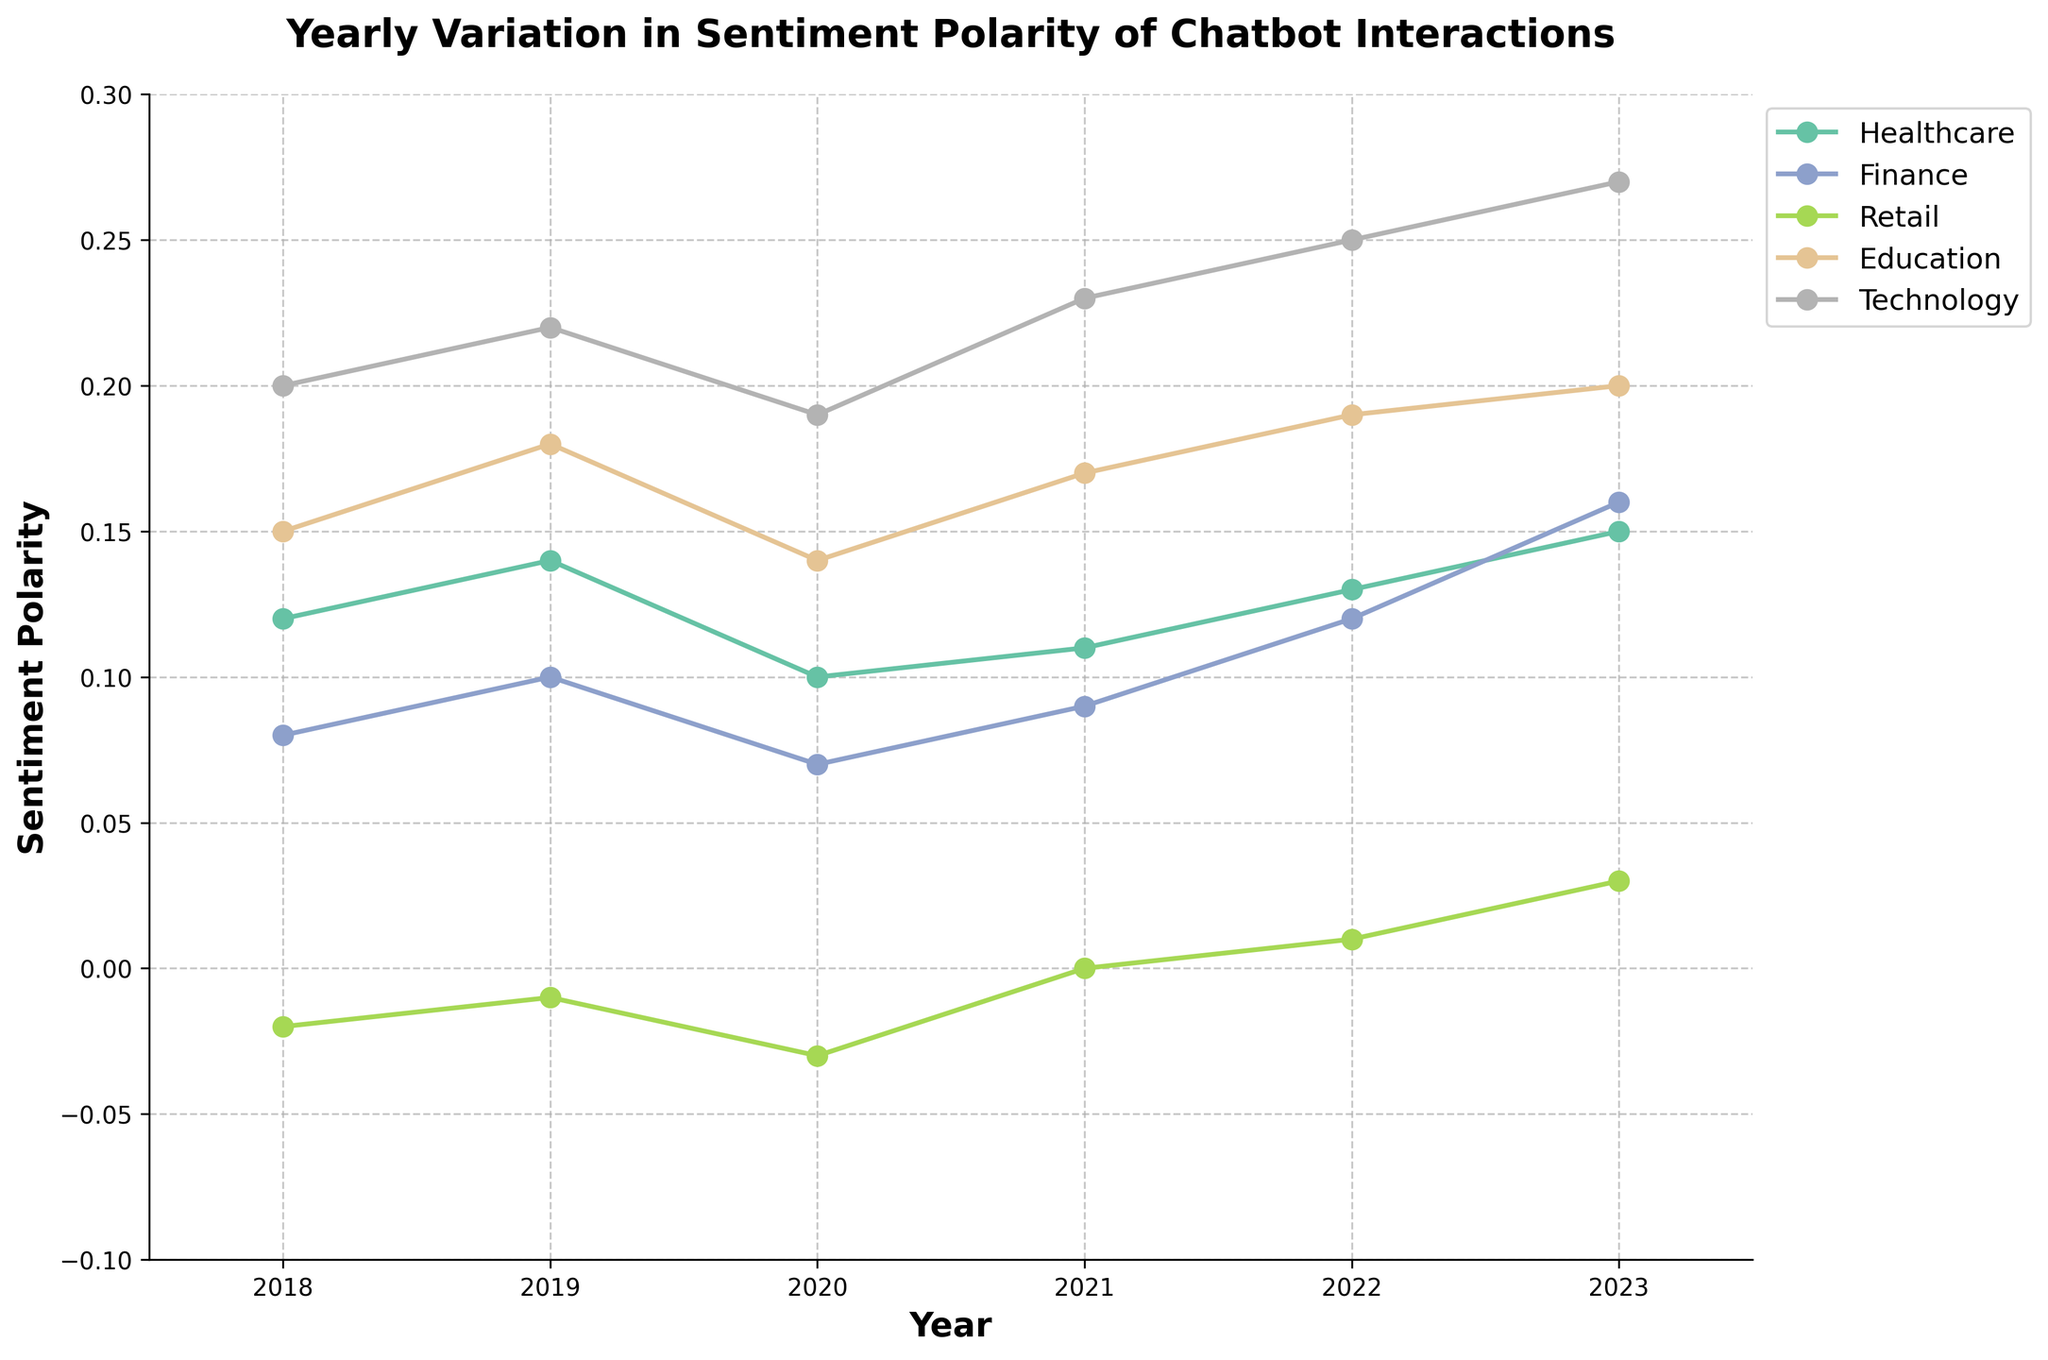What is the title of the plot? The title is positioned above the plot; it gives a summary of what the plot is displaying.
Answer: Yearly Variation in Sentiment Polarity of Chatbot Interactions What year had the lowest sentiment polarity for the Retail industry? The Retail industry line graph shows a dip around 2020 at the bottom of the plot.
Answer: 2020 Which industry had the highest sentiment polarity in 2023? By looking at the endpoint of 2023 for each industry, the Technology industry reaches the highest point.
Answer: Technology How did the sentiment polarity of the Healthcare industry change from 2018 to 2023? Trace the Healthcare line from 2018 to 2023; it starts at 0.12 in 2018 and ends at 0.15 in 2023, showing a slight increase.
Answer: Increased Compare the sentiment polarity between Finance and Education in 2020. Which had a higher value? Look at the values for Finance and Education in 2020; Finance is at 0.07 while Education is at 0.14.
Answer: Education What is the average sentiment polarity for the Technology industry from 2019 to 2022? Sum the values for Technology from 2019 to 2022 (0.22 + 0.19 + 0.23 + 0.25) and divide by 4. (0.89 / 4)
Answer: 0.2225 Did any industry have a negative sentiment polarity value between 2018 and 2023? If so, which industry and year? Scan the plot for negative values, the Retail industry shows a negative value in 2018 and 2020.
Answer: Retail in 2018 and 2020 How many data points are plotted for each industry over the years? Count the markers for one industry line; each year from 2018 to 2023 is marked.
Answer: 6 Identify the period with the steepest increase in sentiment polarity for the Finance industry. Analyze the slope of the Finance industry's line graph; the change between 2022 and 2023 has the steepest incline.
Answer: 2022 to 2023 From 2018 to 2023, which industry saw the largest overall change in sentiment polarity, and what was the value of this change? Calculate the difference between the 2018 and 2023 values for each industry, and identify the maximum difference. Technology (0.27 - 0.20 = 0.07).
Answer: Technology, 0.07 